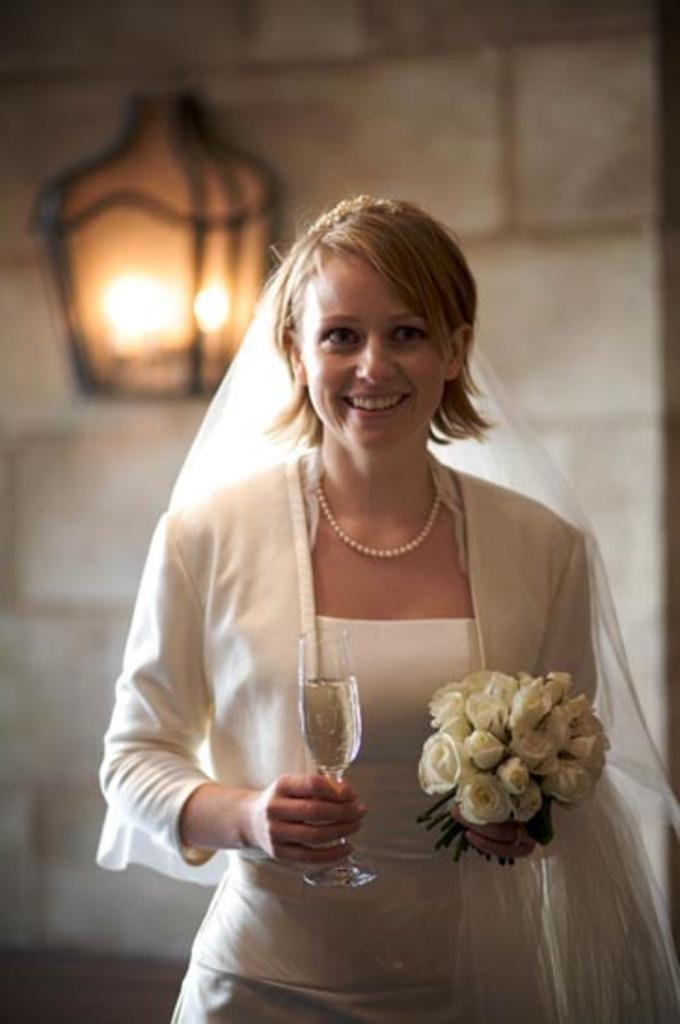Who is present in the image? There is a woman in the image. What is the woman doing in the image? The woman is standing and smiling. What objects is the woman holding in the image? The woman is holding a wine glass and a flower bouquet. What can be seen in the background of the image? There is a lamp in the background of the image. What type of company does the woman own, as seen in the image? There is no indication in the image that the woman owns a company, so it cannot be determined from the picture. 